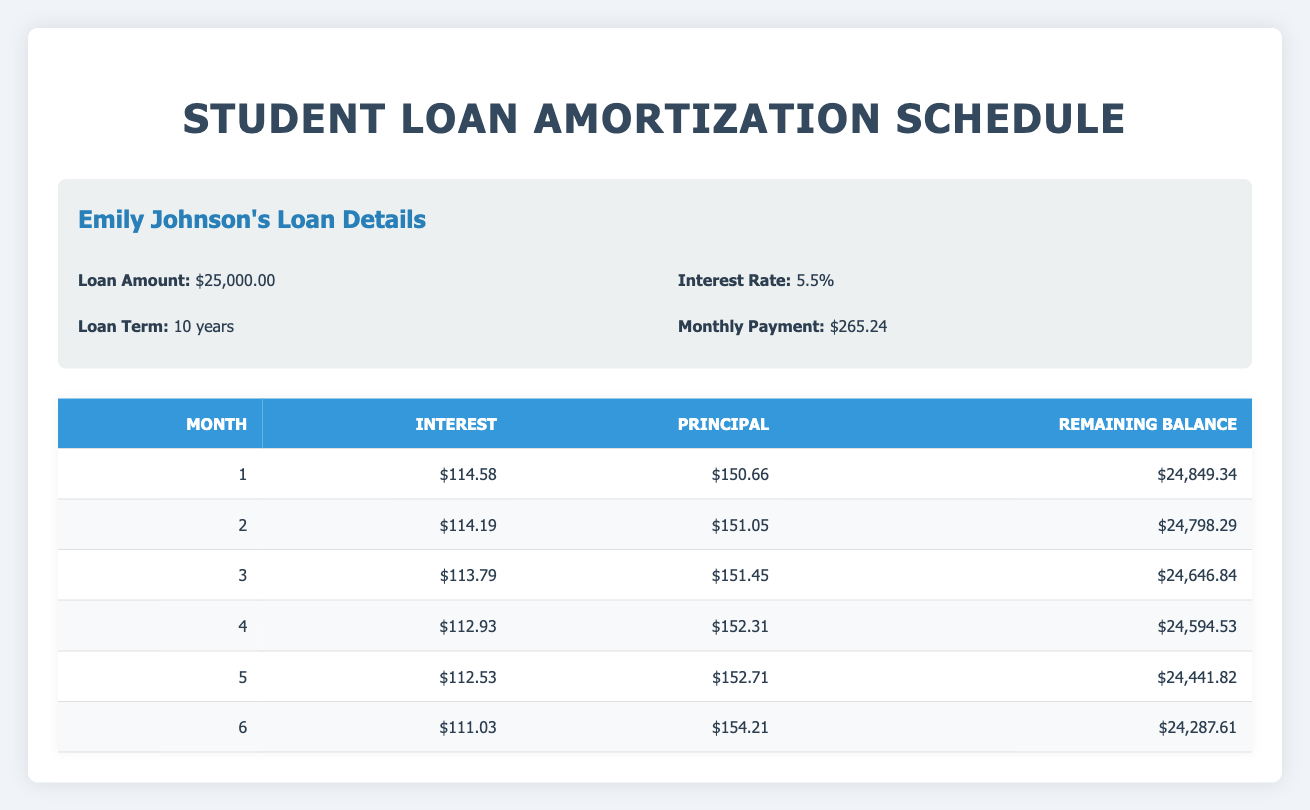What is the monthly payment for Emily Johnson's loan? The table specifies that Emily Johnson's monthly payment is listed under her loan details. It states that her monthly payment is 265.24.
Answer: 265.24 How much principal is paid off in the 3rd month of Emily Johnson's loan? In the table, the monthly amortization schedule shows that the principal paid in the 3rd month is listed directly, which is 151.45.
Answer: 151.45 What is the interest amount for the 5th month of Michael Smith's loan? The table provides the interest for Michael Smith's loan in the amortization section. Specifically, the interest for the 5th month is recorded as 152.09.
Answer: 152.09 Is the interest for Jessica Lee's loan over the first 6 months decreasing? To determine this, we compare the interest amounts for the first six months. The values are: 60.00, 59.94, 59.42, 58.70, 58.08, and 57.46. Since all values are decreasing, the answer is yes.
Answer: Yes What is the remaining balance after month 4 for Emily Johnson? The amortization schedule states that the remaining balance after month 4 for Emily Johnson's loan is listed as 24,594.53.
Answer: 24,594.53 What is the total interest paid over the first 6 months of Jessica Lee's loan? The interest amounts for the first 6 months are: 60.00, 59.94, 59.42, 58.70, 58.08, and 57.46. Adding these gives a total of 60.00 + 59.94 + 59.42 + 58.70 + 58.08 + 57.46 = 353.60.
Answer: 353.60 What is the trend of the principal payment for Michael Smith's loan over the first 6 months? Evaluating the principal payments in the first 6 months gives values of 167.67, 168.38, 169.09, 169.80, 170.51, and 171.22. Each of these values increases, indicating an upward trend.
Answer: Upward trend How much more principal does Emily pay in the 6th month compared to the 1st month? The principal paid in the 6th month is 154.21, and in the 1st month it is 150.66. The difference is calculated as 154.21 - 150.66 = 3.55.
Answer: 3.55 Does Michael Smith's loan have a higher monthly payment than Emily Johnson's loan? Michael Smith's monthly payment is 322.60, while Emily Johnson's is 265.24. Since 322.60 is greater than 265.24, the answer is yes.
Answer: Yes 